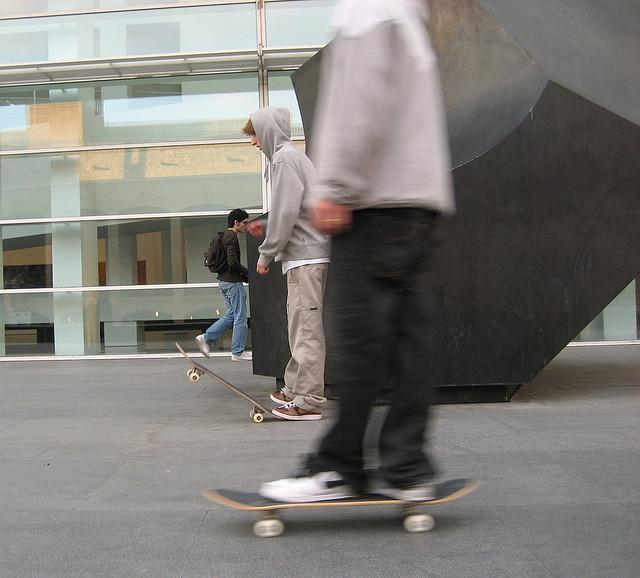How many backpacks are in this photo?
Give a very brief answer. 1. How many skateboard wheels can be seen?
Give a very brief answer. 6. How many people can you see?
Give a very brief answer. 3. How many buses are there?
Give a very brief answer. 0. 